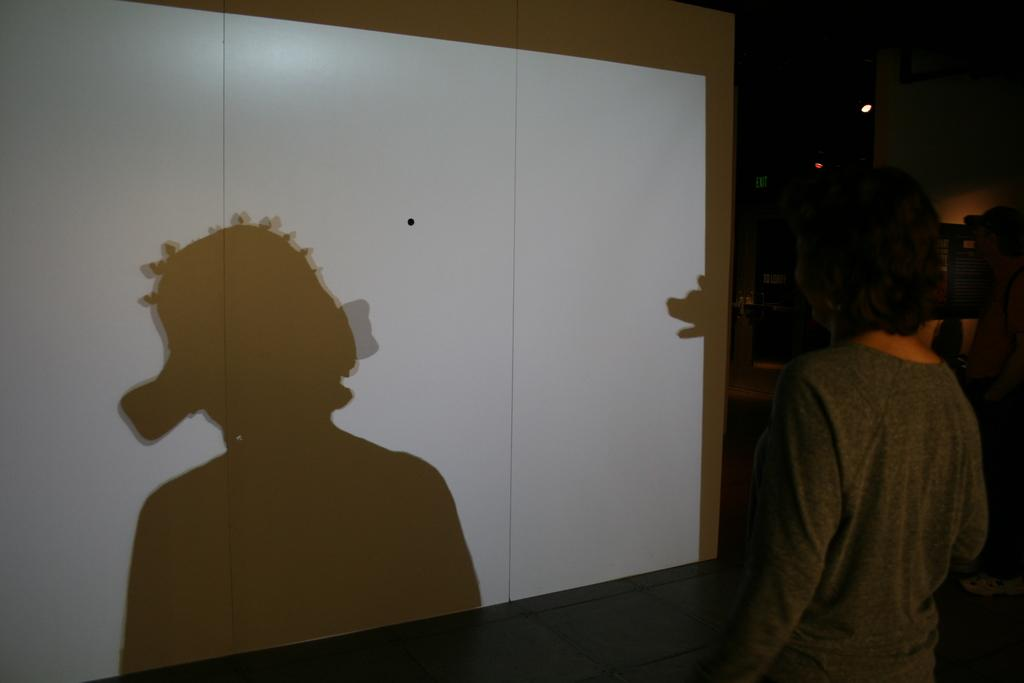Who is present on the right side of the image? There is a woman on the right side of the image. What object can be seen in the image that is typically used for fastening? There is a screw in the image. What is casting a shadow on the screen in the image? There is a shadow on the screen in the image. What can be seen in the background of the image that provides illumination? There is a light in the background of the image. Can you tell me how the man is touching the screw in the image? There is no man present in the image, so it is not possible to determine how a man might be touching the screw. 